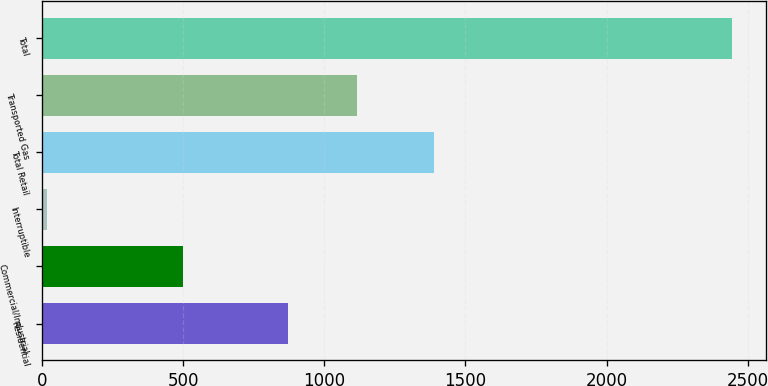Convert chart to OTSL. <chart><loc_0><loc_0><loc_500><loc_500><bar_chart><fcel>Residential<fcel>Commercial/Industrial<fcel>Interruptible<fcel>Total Retail<fcel>Transported Gas<fcel>Total<nl><fcel>872<fcel>499.9<fcel>18.1<fcel>1390<fcel>1114.47<fcel>2442.8<nl></chart> 